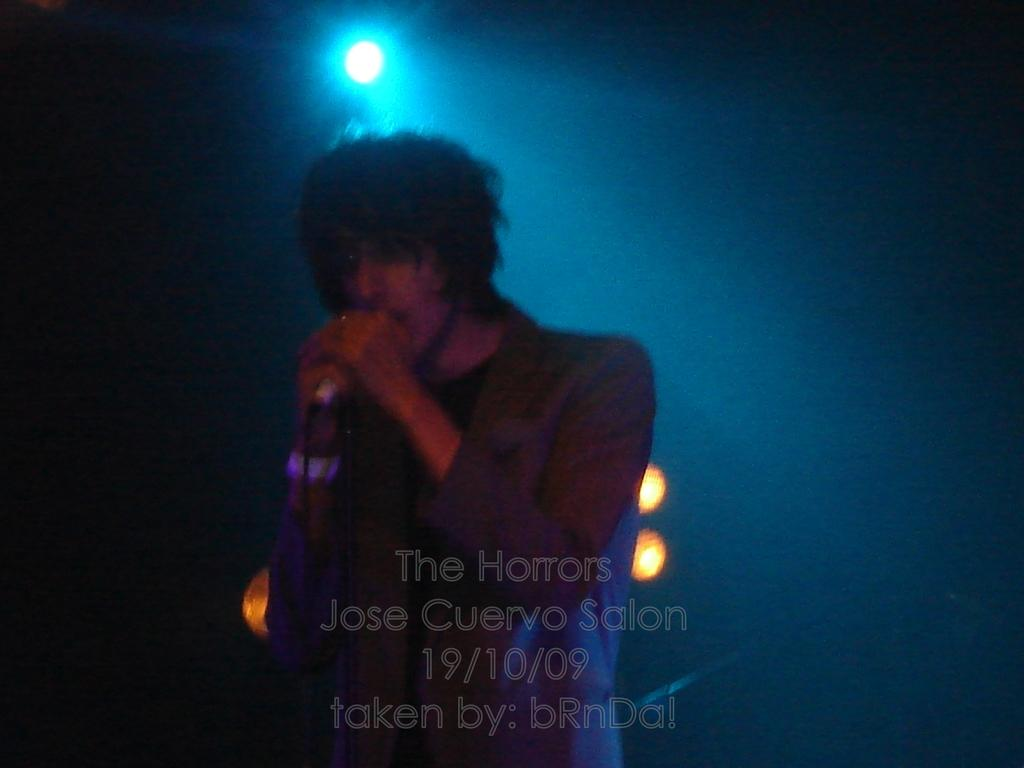Who or what is the main subject in the image? There is a person in the image. What is the person doing in the image? The person is standing and singing. What object is the person holding in the image? The person is holding a microphone. What can be seen in the background of the image? There are lights visible in the background. What type of mint is being used as a prop in the image? There is no mint present in the image; it features a person singing while holding a microphone. What type of quince is being celebrated in the image? There is no quince celebration depicted in the image; it focuses on a person singing with a microphone. 